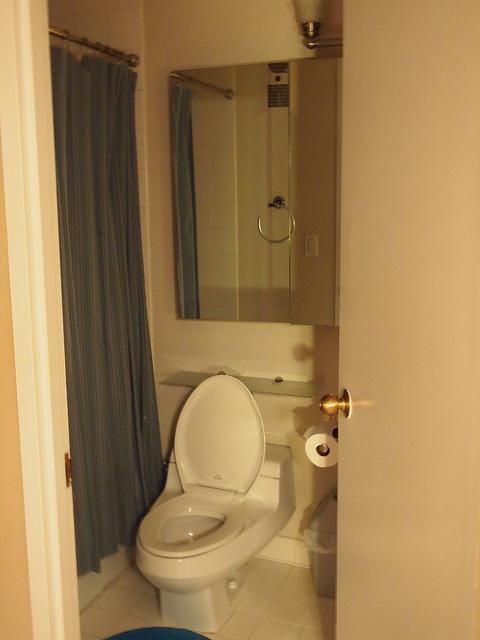How many people are in the kitchen?
Give a very brief answer. 0. 